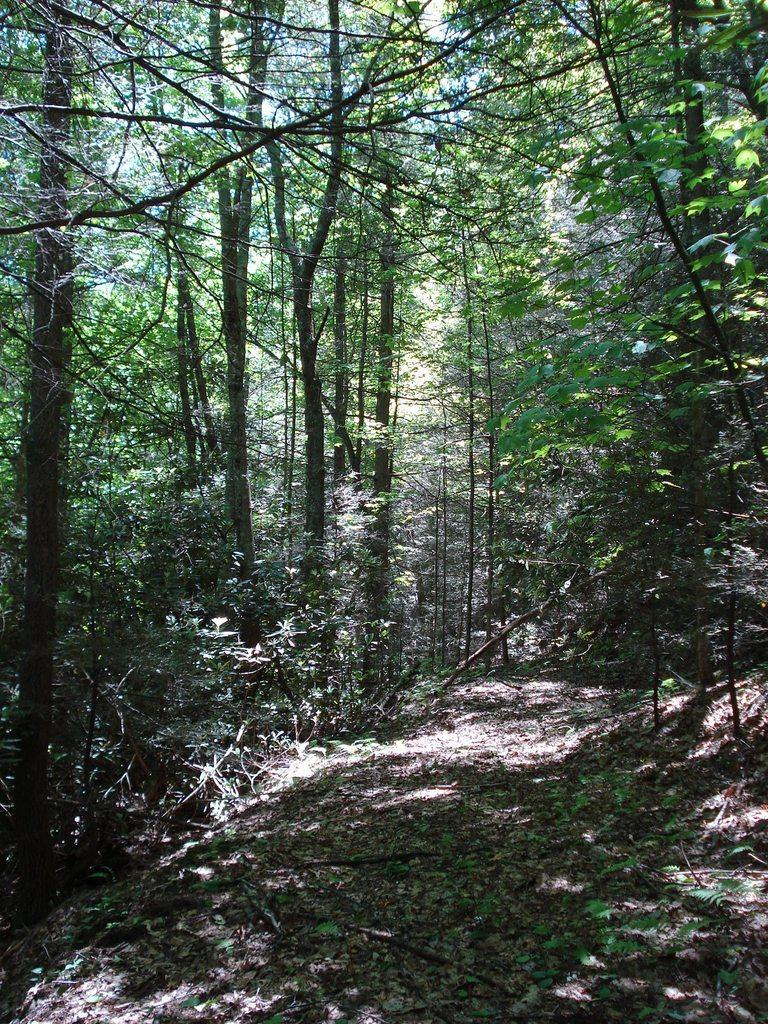What can be seen on the path in the image? There are dry leaves on the path in the image. What is visible in the background of the image? There are trees visible in the background of the image. Can you see any blood on the dry leaves in the image? There is no blood visible on the dry leaves in the image. What type of animal might be leading the group of people in the image? There are no people or animals present in the image, so it is not possible to determine if any are leading a group. 